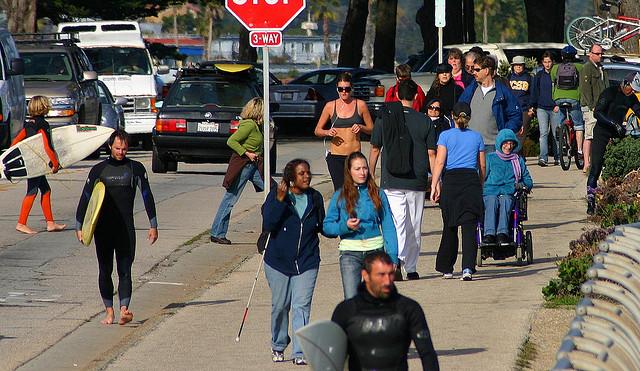Did the woman cross the street safely?
Keep it brief. Yes. What is the popular mode of transportation here?
Concise answer only. Walking. How many people are holding a surfboard?
Be succinct. 2. What kind of vehicle is behind the woman?
Short answer required. Car. What does it say under the stop sign?
Quick response, please. 3-way. Is there a ceiling in the photo?
Write a very short answer. No. What is the weather like?
Keep it brief. Sunny. Is this near the beach?
Give a very brief answer. Yes. 